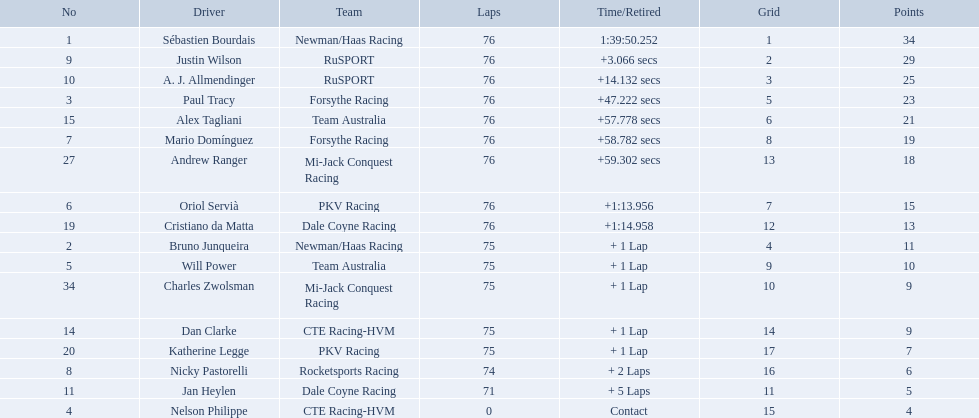What drivers took part in the 2006 tecate grand prix of monterrey? Sébastien Bourdais, Justin Wilson, A. J. Allmendinger, Paul Tracy, Alex Tagliani, Mario Domínguez, Andrew Ranger, Oriol Servià, Cristiano da Matta, Bruno Junqueira, Will Power, Charles Zwolsman, Dan Clarke, Katherine Legge, Nicky Pastorelli, Jan Heylen, Nelson Philippe. Which of those drivers scored the same amount of points as another driver? Charles Zwolsman, Dan Clarke. Give me the full table as a dictionary. {'header': ['No', 'Driver', 'Team', 'Laps', 'Time/Retired', 'Grid', 'Points'], 'rows': [['1', 'Sébastien Bourdais', 'Newman/Haas Racing', '76', '1:39:50.252', '1', '34'], ['9', 'Justin Wilson', 'RuSPORT', '76', '+3.066 secs', '2', '29'], ['10', 'A. J. Allmendinger', 'RuSPORT', '76', '+14.132 secs', '3', '25'], ['3', 'Paul Tracy', 'Forsythe Racing', '76', '+47.222 secs', '5', '23'], ['15', 'Alex Tagliani', 'Team Australia', '76', '+57.778 secs', '6', '21'], ['7', 'Mario Domínguez', 'Forsythe Racing', '76', '+58.782 secs', '8', '19'], ['27', 'Andrew Ranger', 'Mi-Jack Conquest Racing', '76', '+59.302 secs', '13', '18'], ['6', 'Oriol Servià', 'PKV Racing', '76', '+1:13.956', '7', '15'], ['19', 'Cristiano da Matta', 'Dale Coyne Racing', '76', '+1:14.958', '12', '13'], ['2', 'Bruno Junqueira', 'Newman/Haas Racing', '75', '+ 1 Lap', '4', '11'], ['5', 'Will Power', 'Team Australia', '75', '+ 1 Lap', '9', '10'], ['34', 'Charles Zwolsman', 'Mi-Jack Conquest Racing', '75', '+ 1 Lap', '10', '9'], ['14', 'Dan Clarke', 'CTE Racing-HVM', '75', '+ 1 Lap', '14', '9'], ['20', 'Katherine Legge', 'PKV Racing', '75', '+ 1 Lap', '17', '7'], ['8', 'Nicky Pastorelli', 'Rocketsports Racing', '74', '+ 2 Laps', '16', '6'], ['11', 'Jan Heylen', 'Dale Coyne Racing', '71', '+ 5 Laps', '11', '5'], ['4', 'Nelson Philippe', 'CTE Racing-HVM', '0', 'Contact', '15', '4']]} Who had the same amount of points as charles zwolsman? Dan Clarke. Is there a driver named charles zwolsman? Charles Zwolsman. How many points did he acquire? 9. Were there any other entries that got the same number of points? 9. Who did that entry belong to? Dan Clarke. Who drove during the 2006 tecate grand prix of monterrey? Sébastien Bourdais, Justin Wilson, A. J. Allmendinger, Paul Tracy, Alex Tagliani, Mario Domínguez, Andrew Ranger, Oriol Servià, Cristiano da Matta, Bruno Junqueira, Will Power, Charles Zwolsman, Dan Clarke, Katherine Legge, Nicky Pastorelli, Jan Heylen, Nelson Philippe. And what were their finishing positions? 1, 2, 3, 4, 5, 6, 7, 8, 9, 10, 11, 12, 13, 14, 15, 16, 17. Who did alex tagliani finish directly behind of? Paul Tracy. 